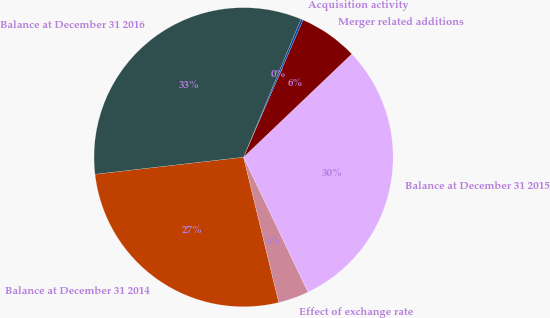Convert chart. <chart><loc_0><loc_0><loc_500><loc_500><pie_chart><fcel>Balance at December 31 2014<fcel>Effect of exchange rate<fcel>Balance at December 31 2015<fcel>Merger related additions<fcel>Acquisition activity<fcel>Balance at December 31 2016<nl><fcel>26.96%<fcel>3.31%<fcel>30.03%<fcel>6.37%<fcel>0.24%<fcel>33.09%<nl></chart> 